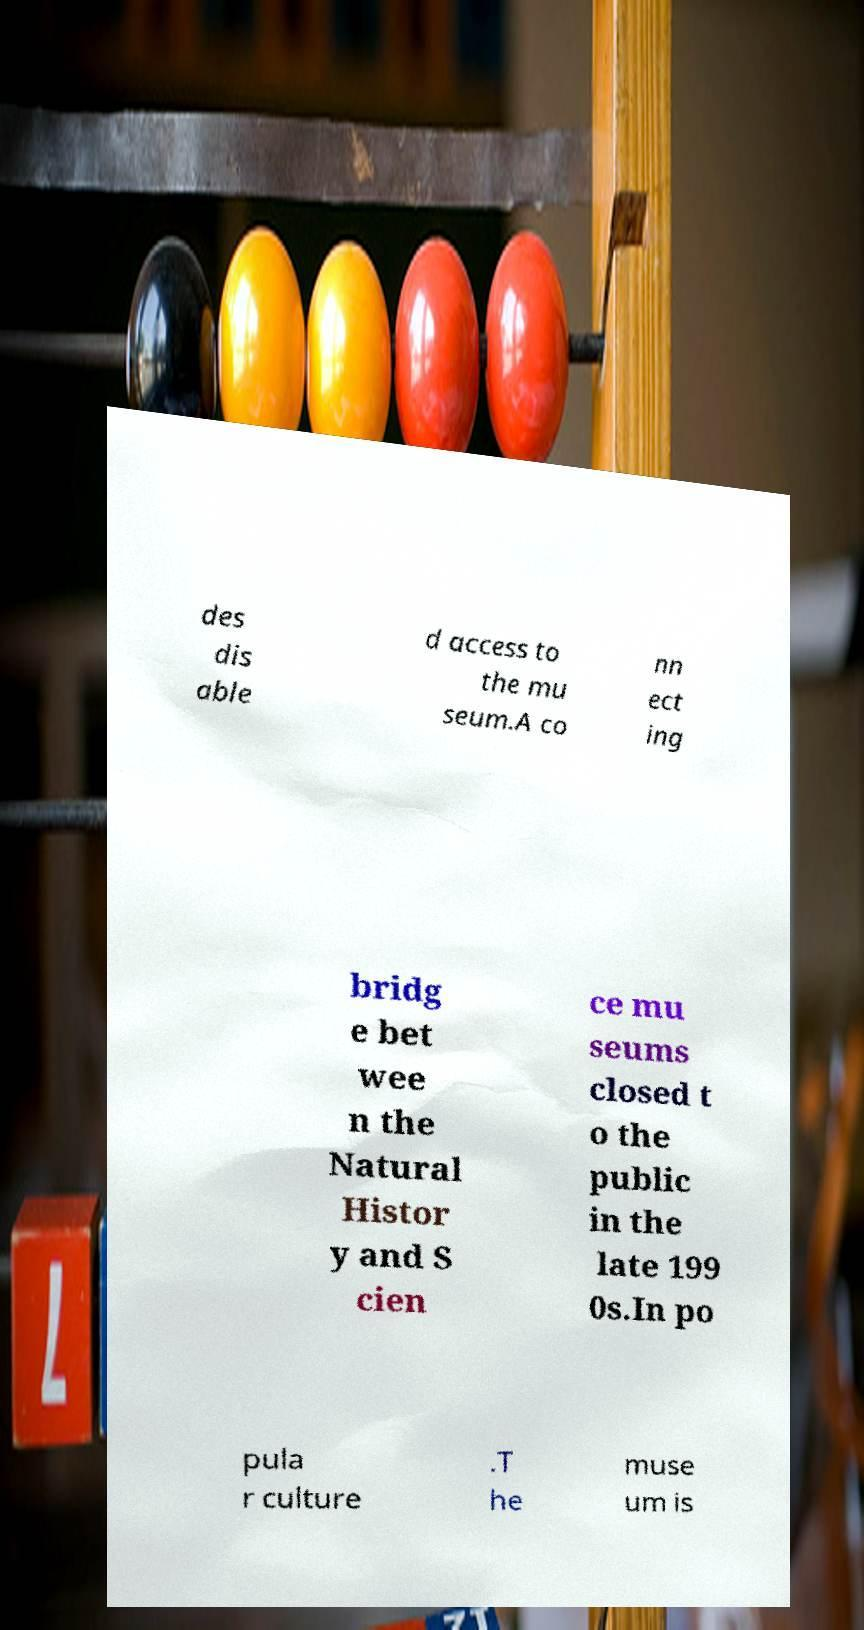Could you assist in decoding the text presented in this image and type it out clearly? des dis able d access to the mu seum.A co nn ect ing bridg e bet wee n the Natural Histor y and S cien ce mu seums closed t o the public in the late 199 0s.In po pula r culture .T he muse um is 